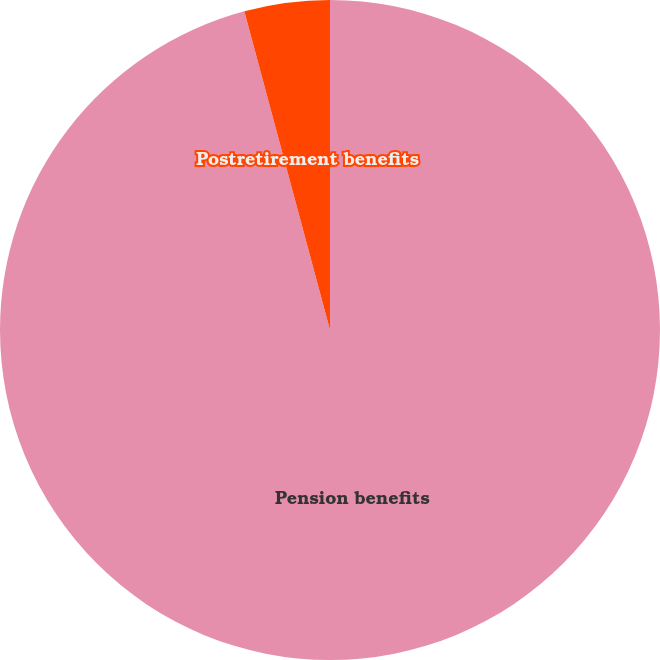<chart> <loc_0><loc_0><loc_500><loc_500><pie_chart><fcel>Pension benefits<fcel>Postretirement benefits<nl><fcel>95.82%<fcel>4.18%<nl></chart> 